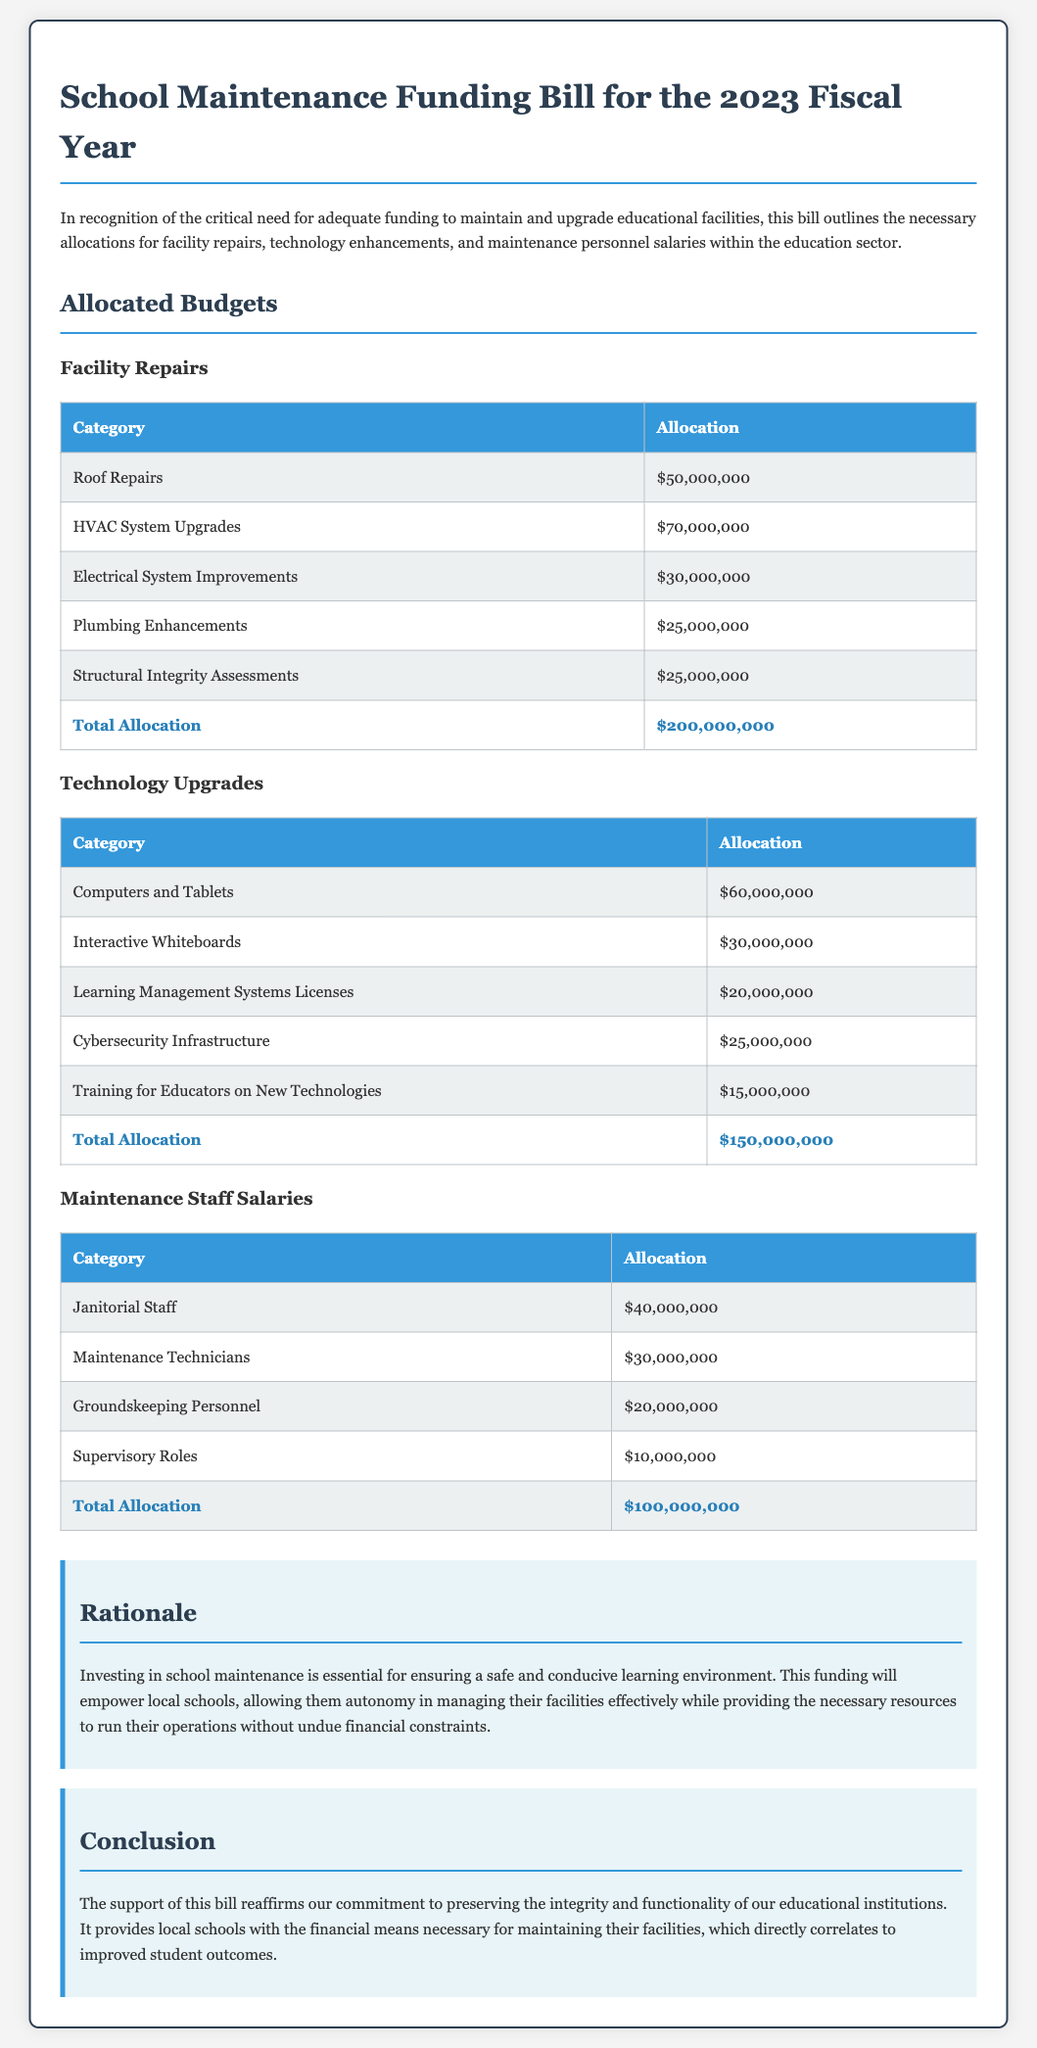What is the total allocation for facility repairs? The total allocation for facility repairs is listed in the document as $200,000,000.
Answer: $200,000,000 How much is allocated for technology upgrades? The allocation for technology upgrades is specifically mentioned in the budget section as $150,000,000.
Answer: $150,000,000 What is the budget for supervisory roles salaries? The budget for supervisory roles salaries totals $10,000,000 as indicated in the maintenance staff salaries section.
Answer: $10,000,000 Which category has the highest allocation in facility repairs? The category with the highest allocation in facility repairs is HVAC System Upgrades, which is allocated $70,000,000.
Answer: HVAC System Upgrades What total amount is earmarked for training educators on new technologies? The document specifies a total allocation of $15,000,000 for training educators on new technologies.
Answer: $15,000,000 What is the purpose of the School Maintenance Funding Bill? The purpose of the bill is to outline funding for necessary allocations in facility repairs, technology enhancements, and maintenance personnel salaries.
Answer: Funding allocations What rationale is given for investing in school maintenance? The rationale states that investing in school maintenance is essential for ensuring a safe and conducive learning environment.
Answer: Safe and conducive learning environment How many categories are detailed in the technology upgrades section? The technology upgrades section details five categories of budget allocations.
Answer: Five categories 